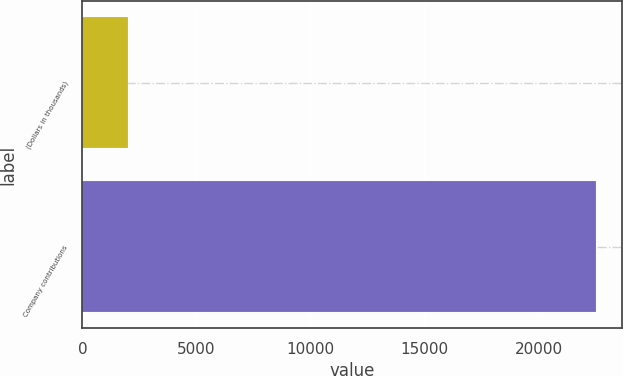Convert chart. <chart><loc_0><loc_0><loc_500><loc_500><bar_chart><fcel>(Dollars in thousands)<fcel>Company contributions<nl><fcel>2013<fcel>22536<nl></chart> 